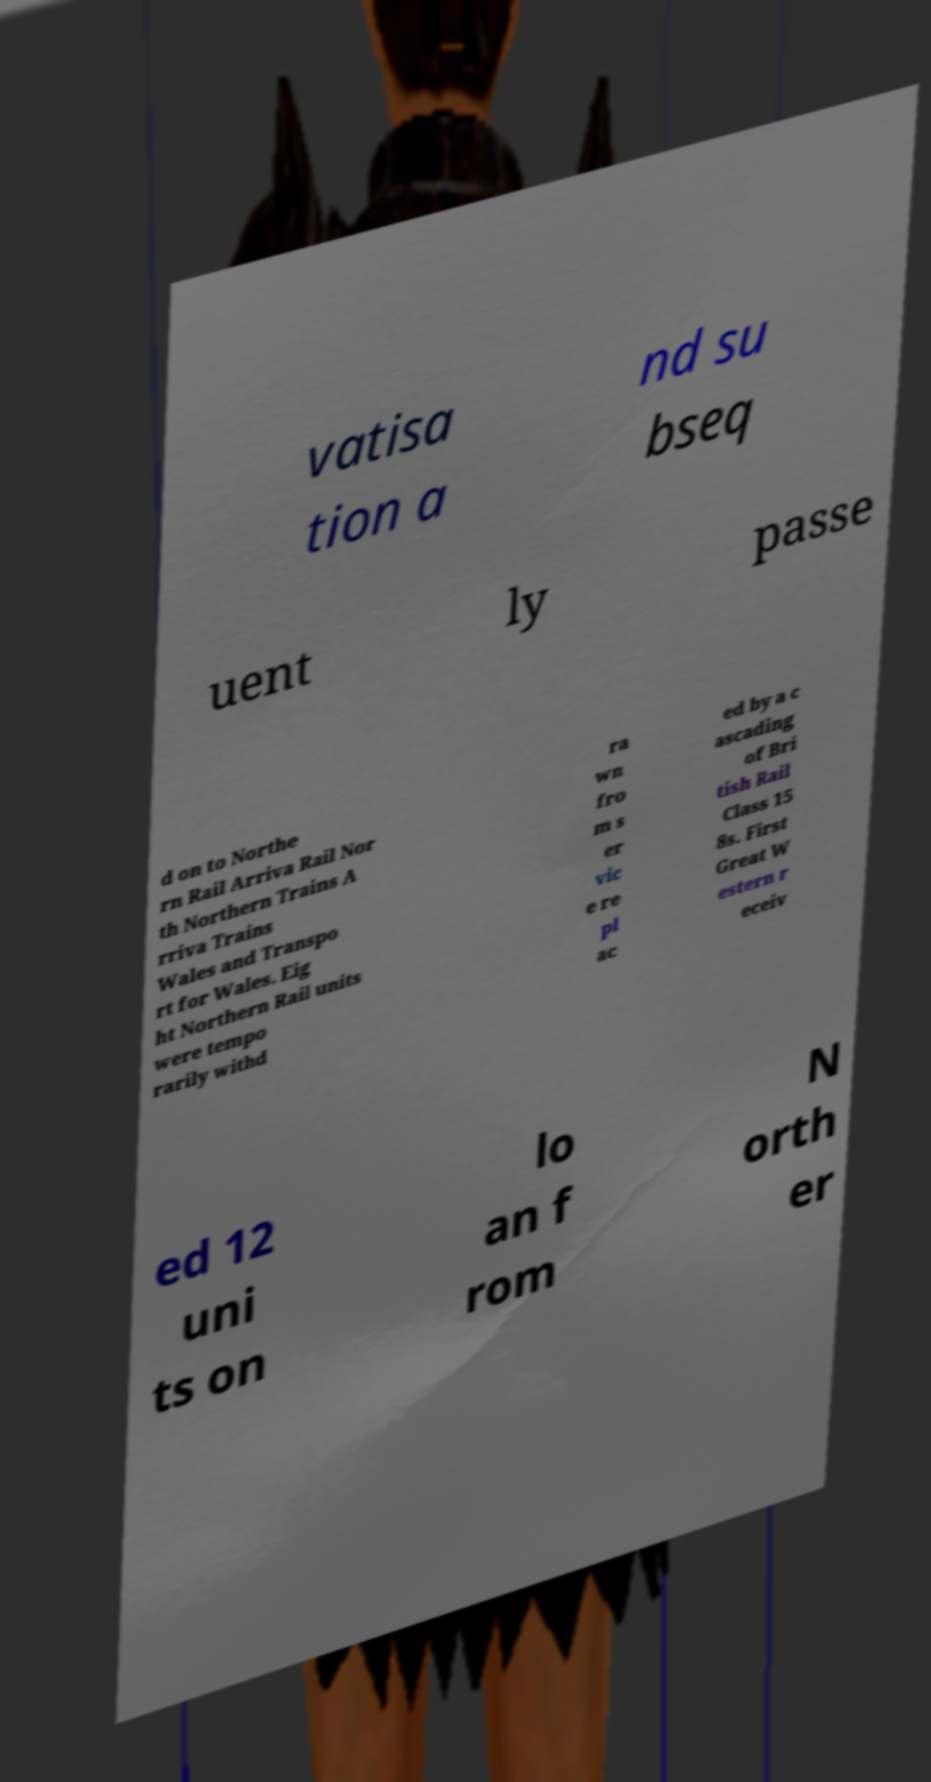What messages or text are displayed in this image? I need them in a readable, typed format. vatisa tion a nd su bseq uent ly passe d on to Northe rn Rail Arriva Rail Nor th Northern Trains A rriva Trains Wales and Transpo rt for Wales. Eig ht Northern Rail units were tempo rarily withd ra wn fro m s er vic e re pl ac ed by a c ascading of Bri tish Rail Class 15 8s. First Great W estern r eceiv ed 12 uni ts on lo an f rom N orth er 